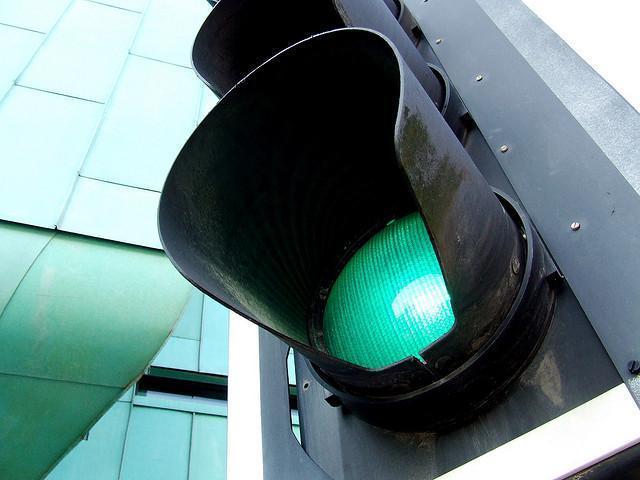How many cups are there?
Give a very brief answer. 0. 